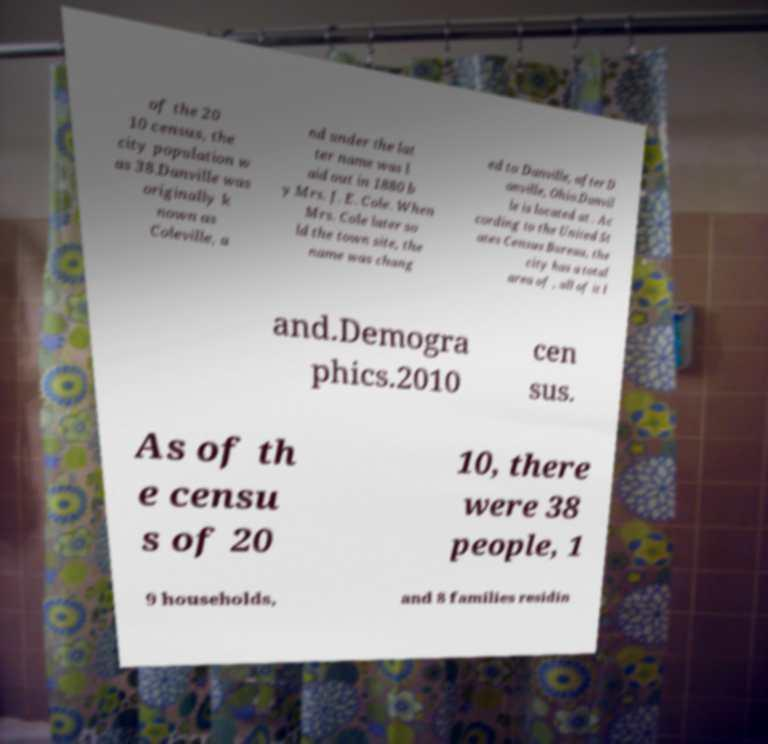For documentation purposes, I need the text within this image transcribed. Could you provide that? of the 20 10 census, the city population w as 38.Danville was originally k nown as Coleville, a nd under the lat ter name was l aid out in 1880 b y Mrs. J. E. Cole. When Mrs. Cole later so ld the town site, the name was chang ed to Danville, after D anville, Ohio.Danvil le is located at . Ac cording to the United St ates Census Bureau, the city has a total area of , all of it l and.Demogra phics.2010 cen sus. As of th e censu s of 20 10, there were 38 people, 1 9 households, and 8 families residin 